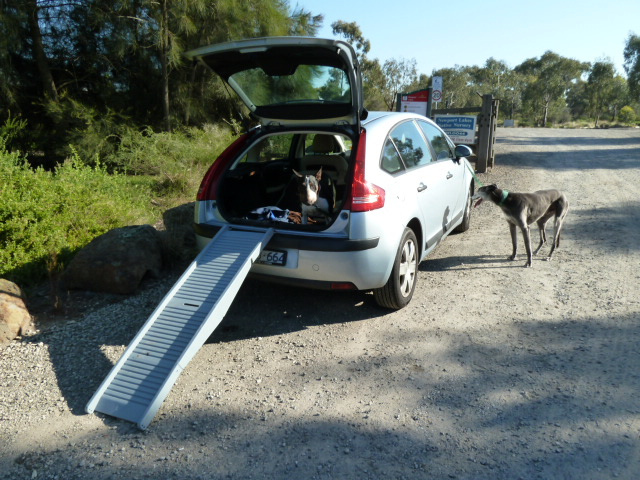What uses the ramp on the back of the car?
A. cats
B. babies
C. dogs
D. birds The ramp on the back of the car is used by dogs to easily get in and out of the vehicle, ensuring safety and convenience, especially for older or mobility-impaired dogs. 